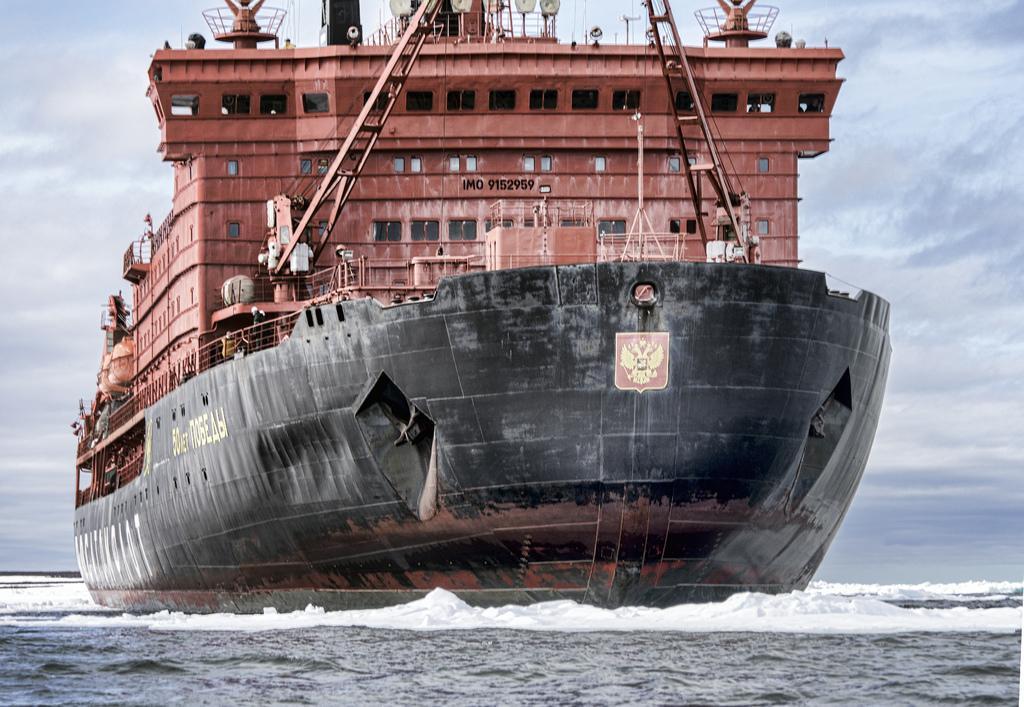How would you summarize this image in a sentence or two? In this image there is a ship sailing on a sea, in the background there is a cloudy sky. 